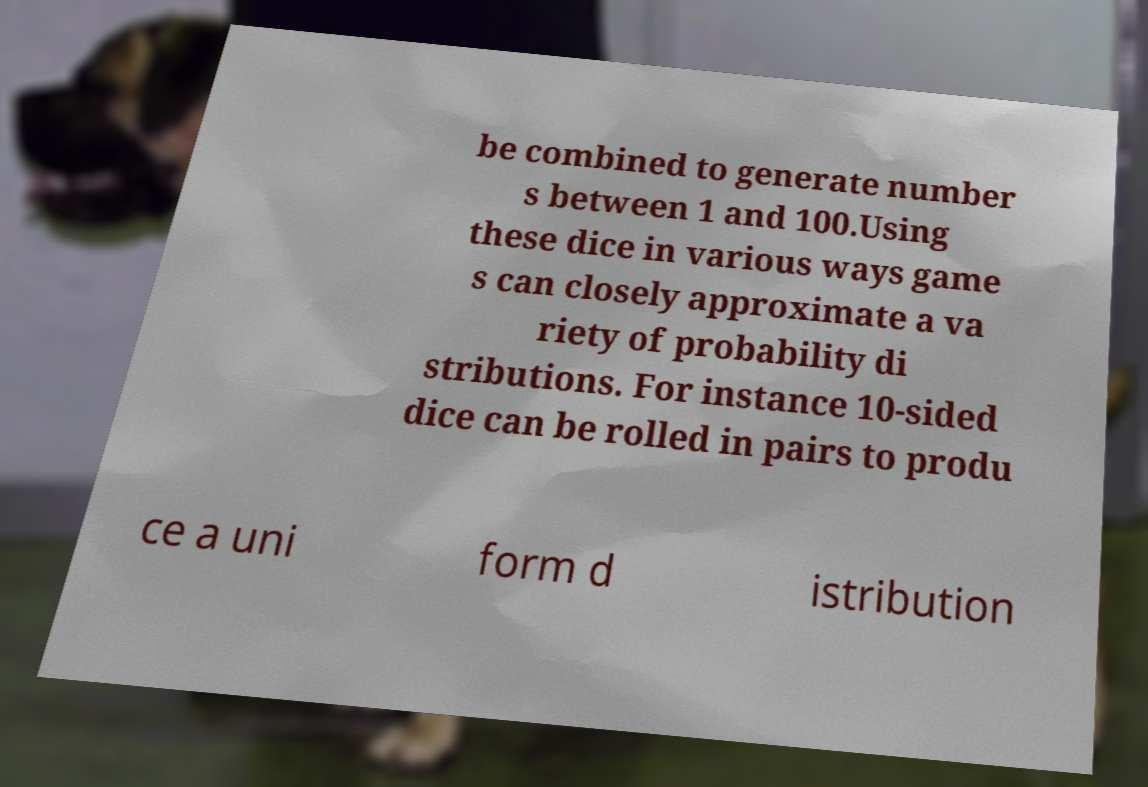Please read and relay the text visible in this image. What does it say? be combined to generate number s between 1 and 100.Using these dice in various ways game s can closely approximate a va riety of probability di stributions. For instance 10-sided dice can be rolled in pairs to produ ce a uni form d istribution 